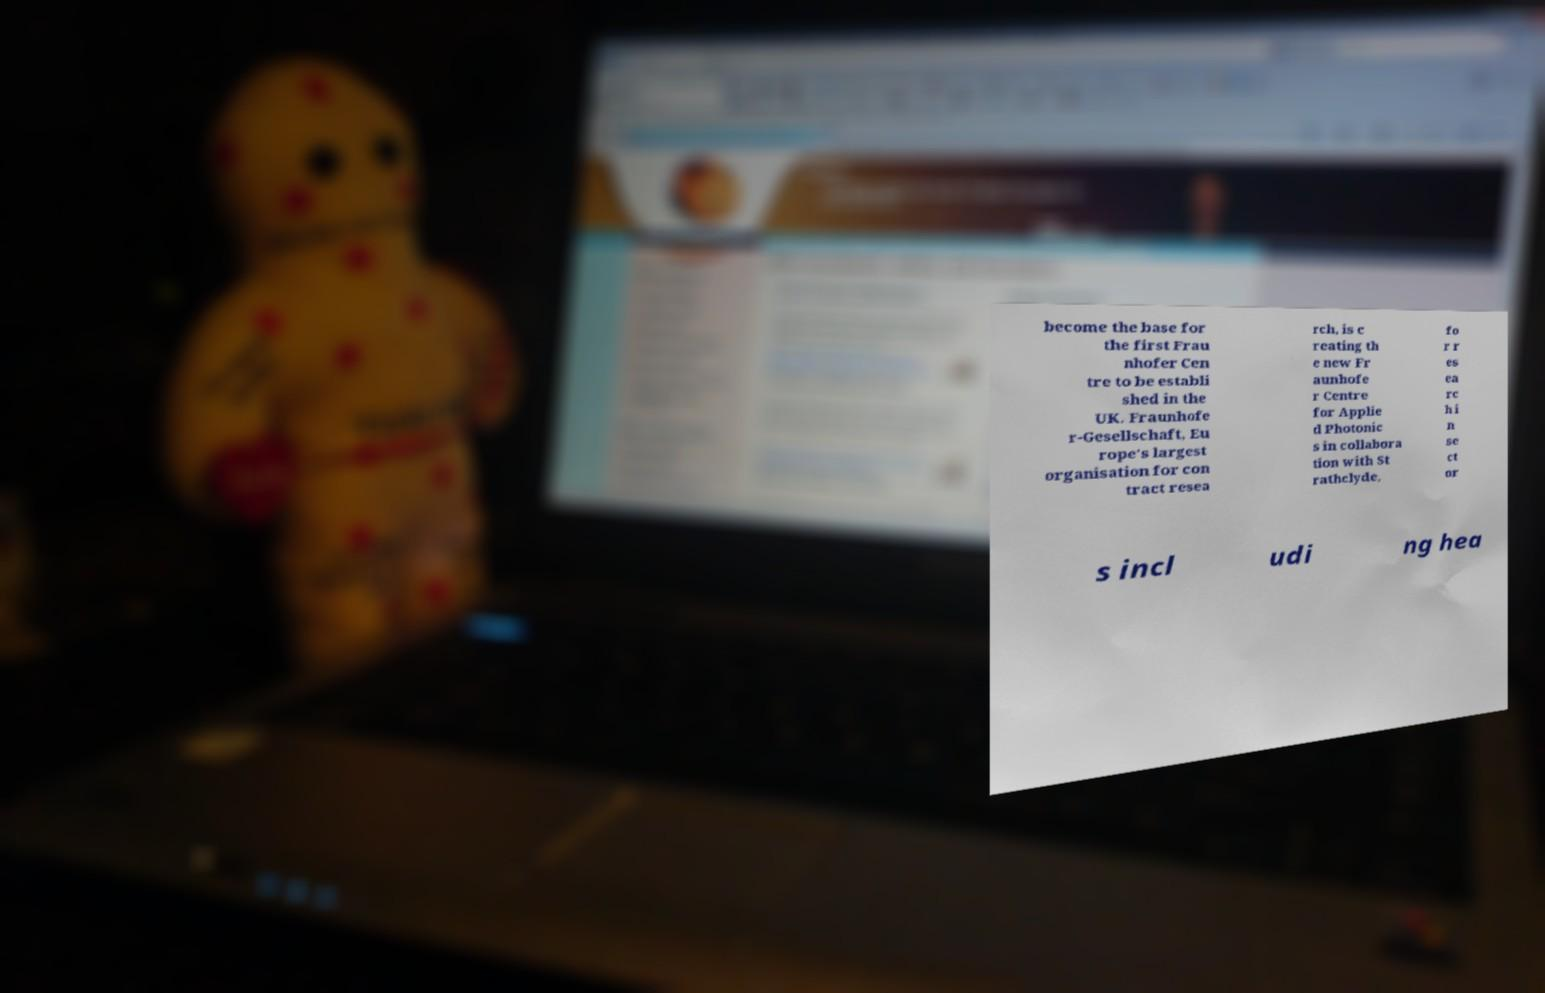For documentation purposes, I need the text within this image transcribed. Could you provide that? become the base for the first Frau nhofer Cen tre to be establi shed in the UK. Fraunhofe r-Gesellschaft, Eu rope's largest organisation for con tract resea rch, is c reating th e new Fr aunhofe r Centre for Applie d Photonic s in collabora tion with St rathclyde, fo r r es ea rc h i n se ct or s incl udi ng hea 